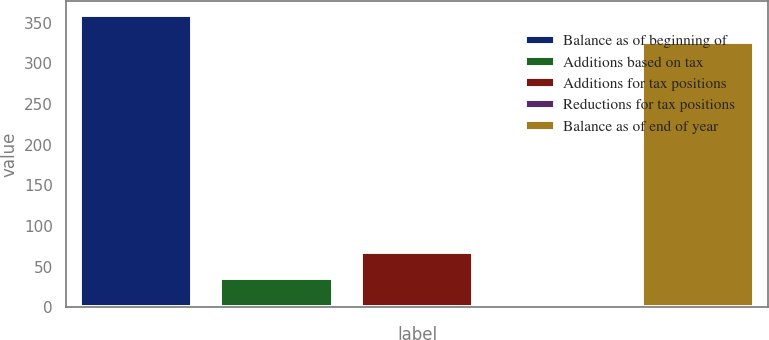<chart> <loc_0><loc_0><loc_500><loc_500><bar_chart><fcel>Balance as of beginning of<fcel>Additions based on tax<fcel>Additions for tax positions<fcel>Reductions for tax positions<fcel>Balance as of end of year<nl><fcel>358.7<fcel>35.7<fcel>68.4<fcel>3<fcel>326<nl></chart> 